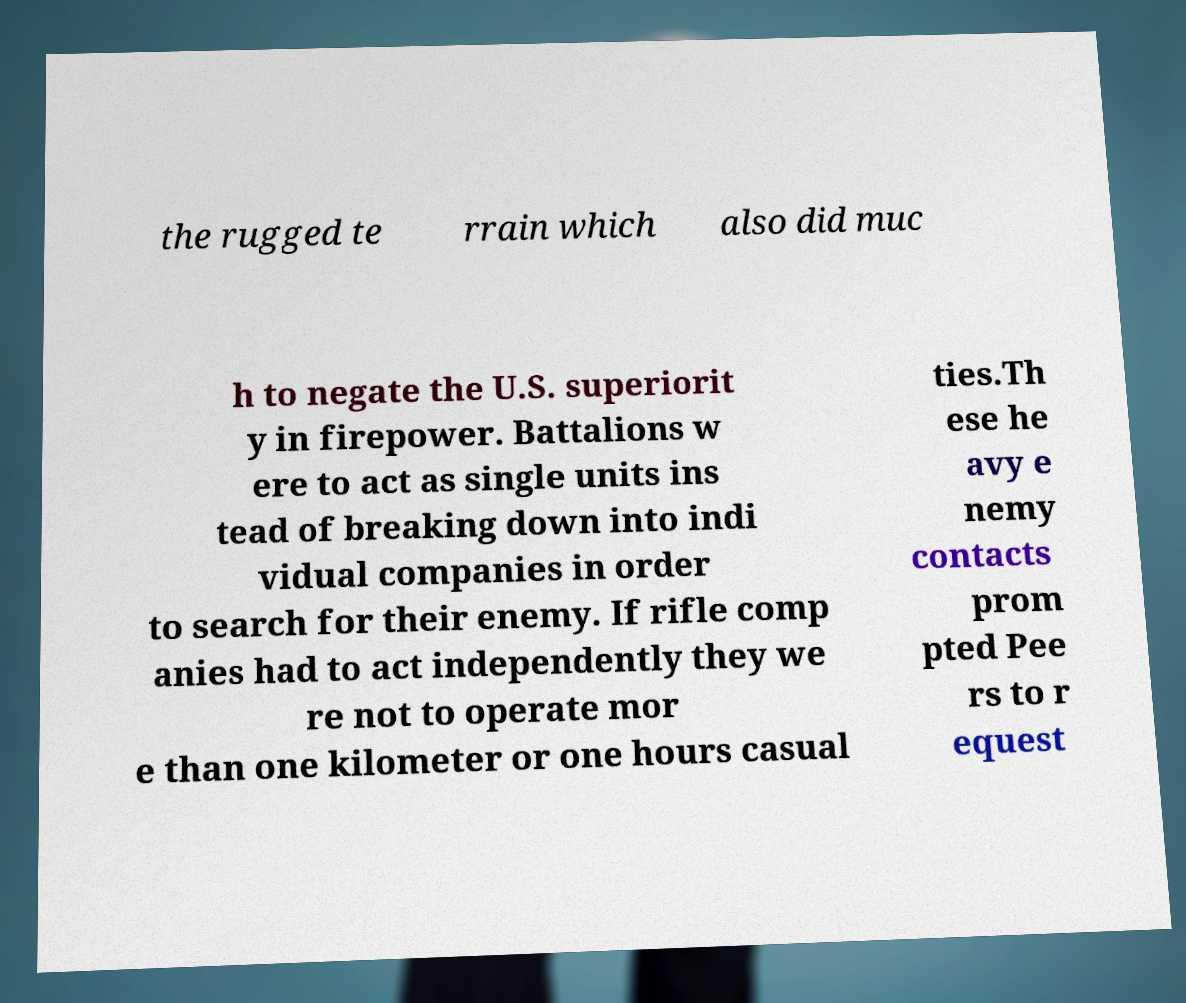Could you extract and type out the text from this image? the rugged te rrain which also did muc h to negate the U.S. superiorit y in firepower. Battalions w ere to act as single units ins tead of breaking down into indi vidual companies in order to search for their enemy. If rifle comp anies had to act independently they we re not to operate mor e than one kilometer or one hours casual ties.Th ese he avy e nemy contacts prom pted Pee rs to r equest 